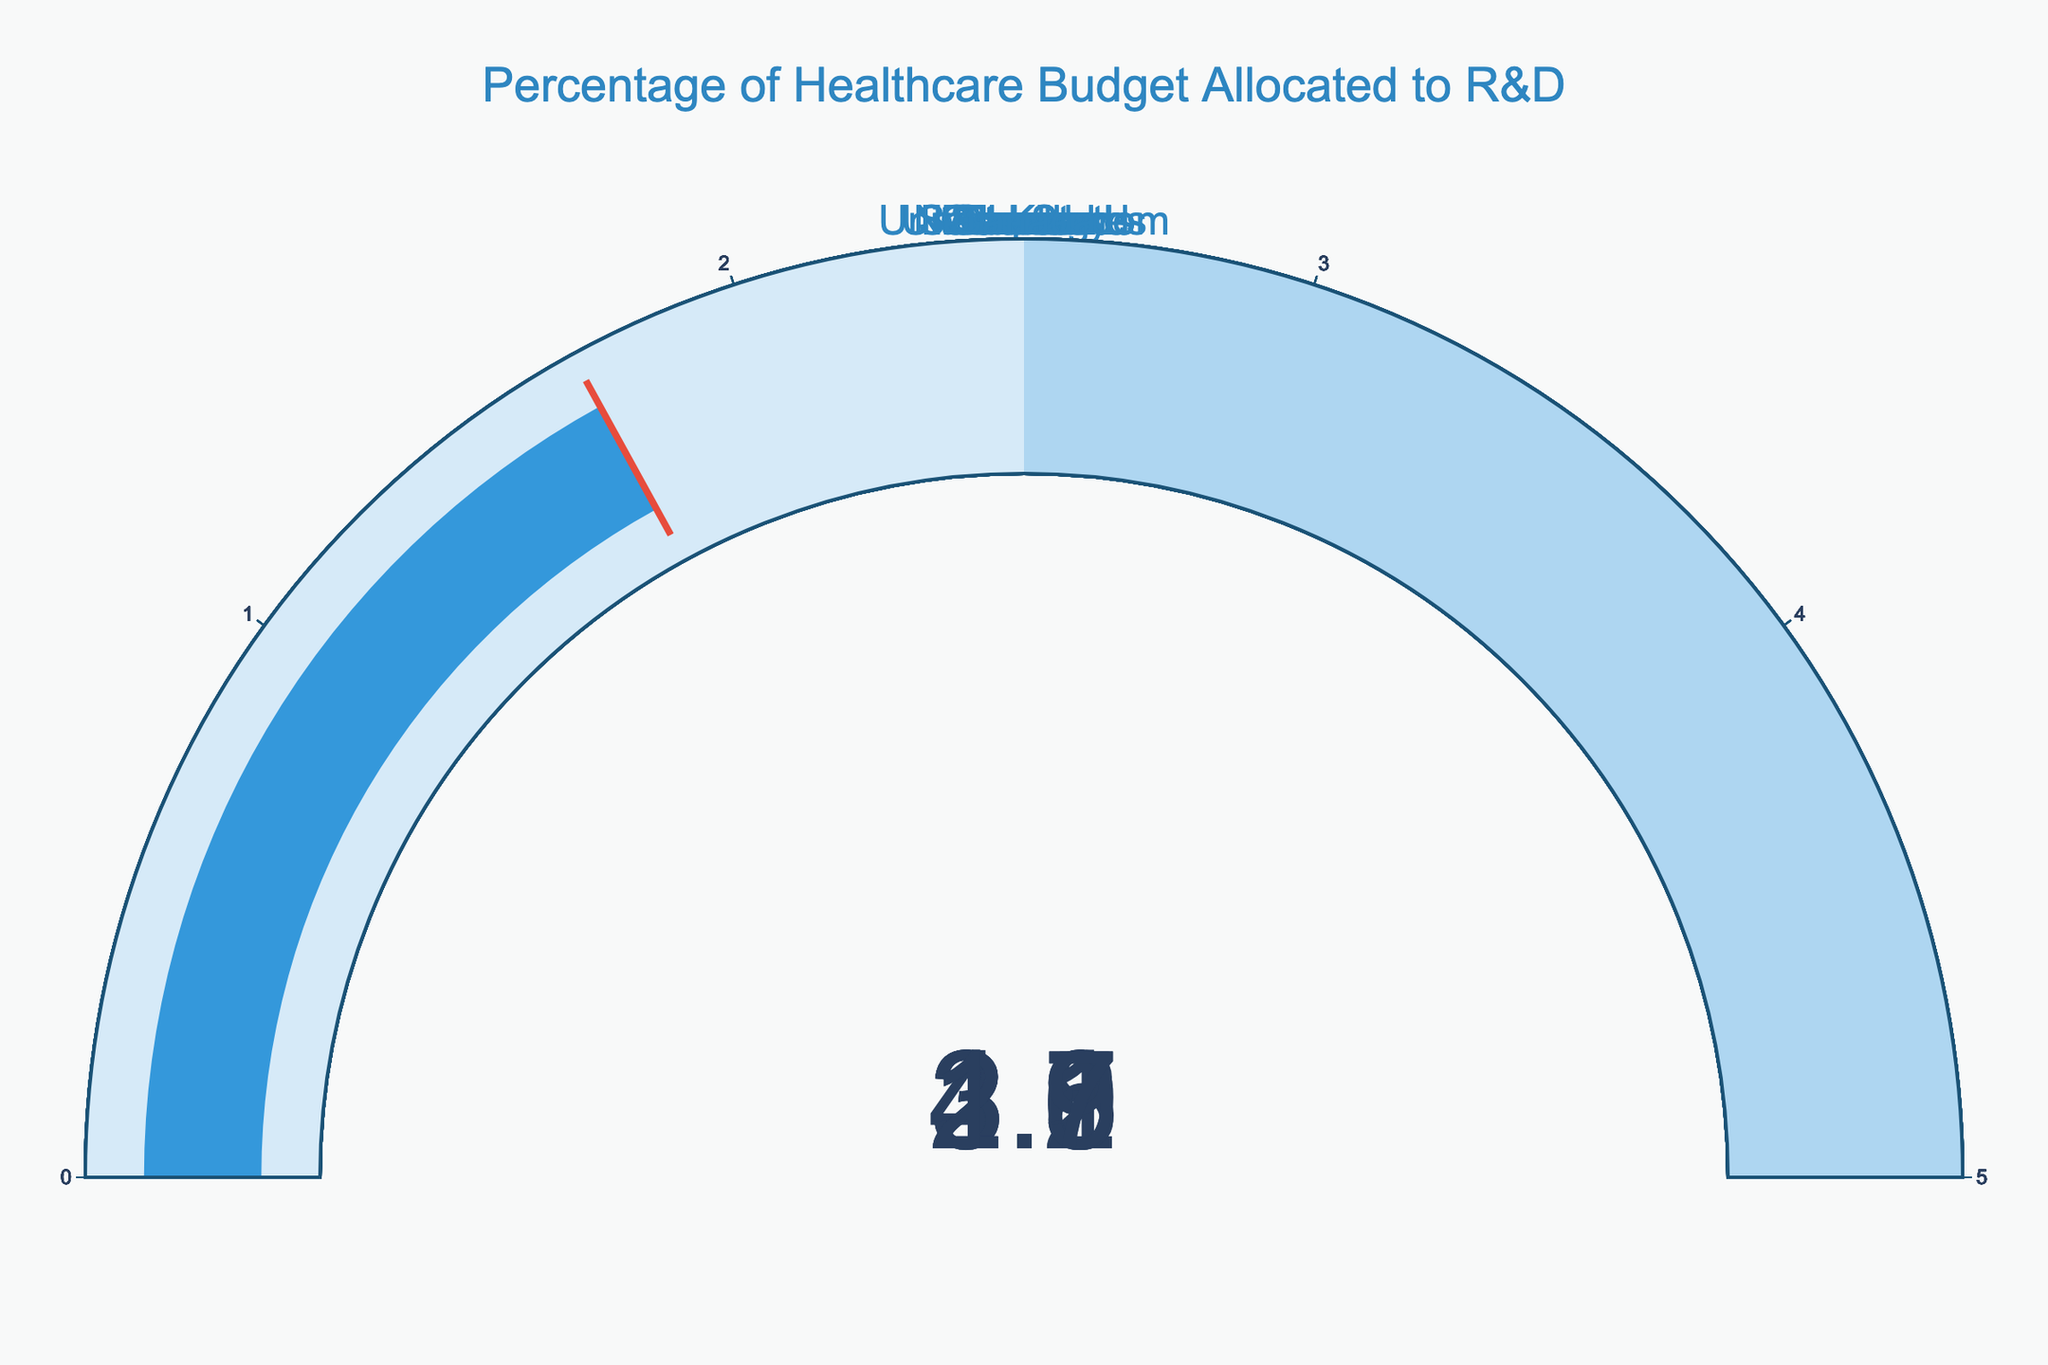What is the title of the gauge chart? The title of the gauge chart is located at the top and is written in a larger font compared to the rest of the text in the figure.
Answer: Percentage of Healthcare Budget Allocated to R&D How many countries are represented in the gauge chart? Each gauge in the chart represents a different country, and one can count the total number of distinct gauges to determine the number of countries.
Answer: 10 Which country allocates the highest percentage of its healthcare budget to R&D? By observing the values displayed on each gauge, the country with the highest percentage can be identified.
Answer: United States What is the difference in R&D budget percentage between the country with the highest and the country with the lowest allocation? Identify the highest (United States: 4.7%) and lowest (Canada: 1.7%) values, and compute the difference by subtracting the lowest from the highest.
Answer: 3.0 Which countries allocate more than 3% of their healthcare budget to R&D? Examine the gauges and identify all countries with a value greater than 3.0%.
Answer: United States, Germany, Japan, United Kingdom What's the average percentage of healthcare budget allocated to R&D across all countries? Sum all the R&D percentages and divide by the total number of countries (10). (4.7 + 3.9 + 3.5 + 3.2 + 2.8 + 2.6 + 2.3 + 2.1 + 1.9 + 1.7) = 28.7; 28.7 / 10 = 2.87
Answer: 2.87 Between Germany and France, which country allocates more to R&D, and by how much? Compare the values for Germany (3.9%) and France (2.8%), and subtract the smaller value from the larger one.
Answer: Germany by 1.1% How many countries allocate less than 2.5% of their healthcare budget to R&D? Count the number of gauges with values less than 2.5%.
Answer: 5 Are there any countries that allocate exactly the same percentage of their healthcare budget to R&D? Check the gauges to see if any two or more countries have the same displayed value.
Answer: No 